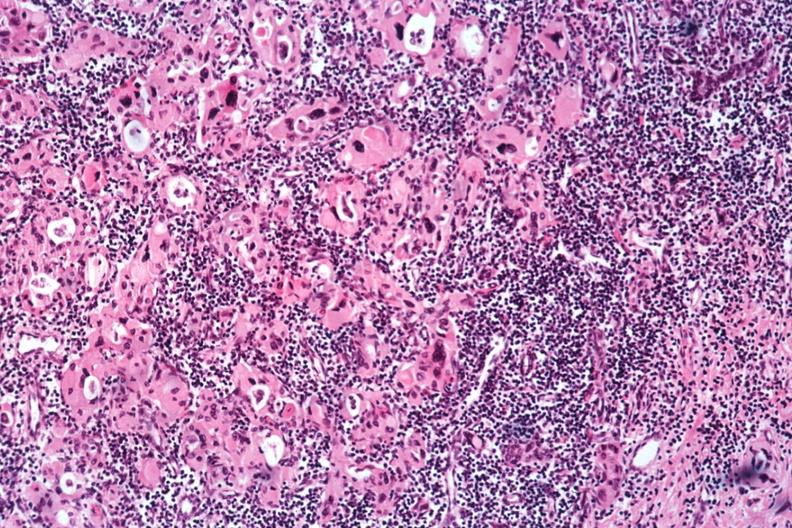s endocrine present?
Answer the question using a single word or phrase. Yes 